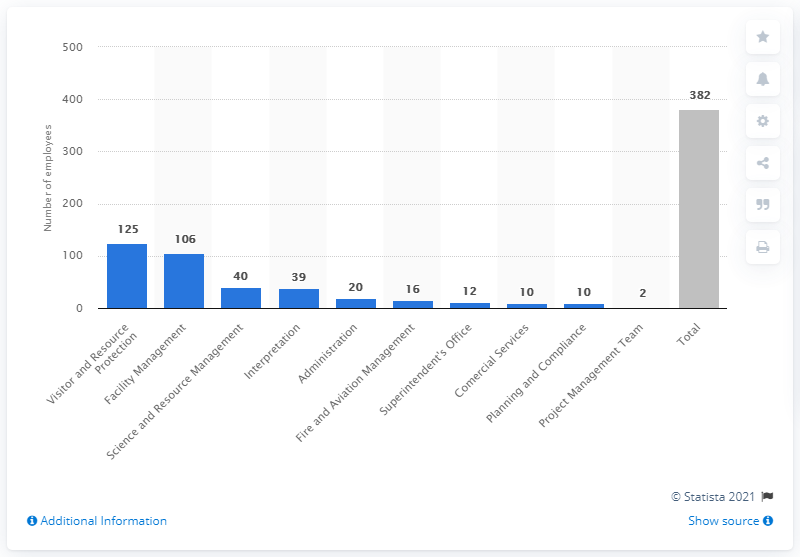Outline some significant characteristics in this image. In 2018, Grand Canyon National Park had a total of 382 employees. In the field of Visitor and Resource protection, 125 people were employed. 